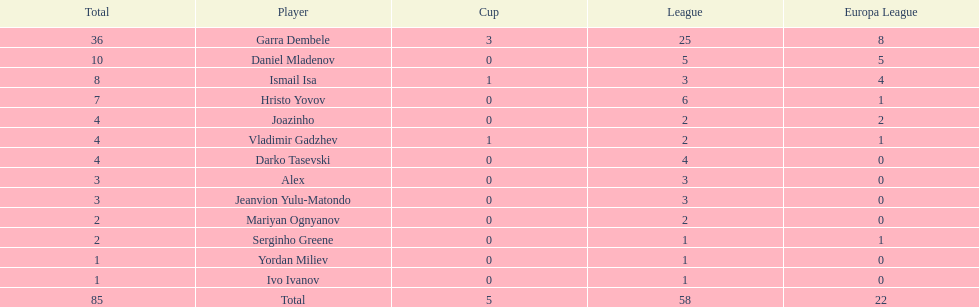What is the sum of the cup total and the europa league total? 27. 